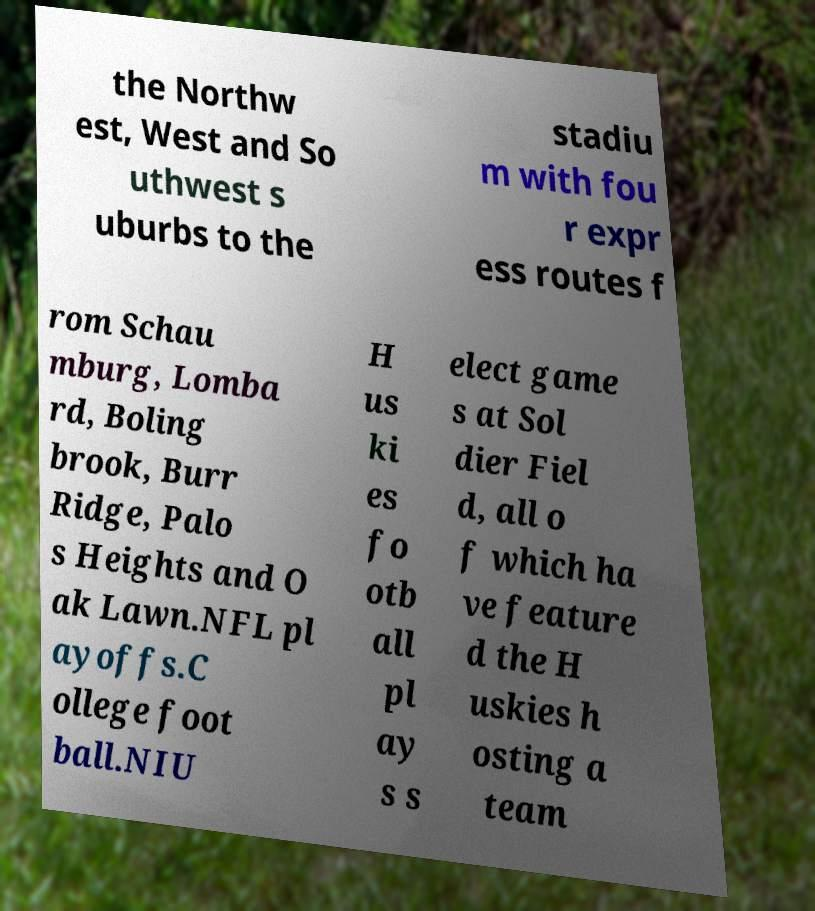Could you extract and type out the text from this image? the Northw est, West and So uthwest s uburbs to the stadiu m with fou r expr ess routes f rom Schau mburg, Lomba rd, Boling brook, Burr Ridge, Palo s Heights and O ak Lawn.NFL pl ayoffs.C ollege foot ball.NIU H us ki es fo otb all pl ay s s elect game s at Sol dier Fiel d, all o f which ha ve feature d the H uskies h osting a team 